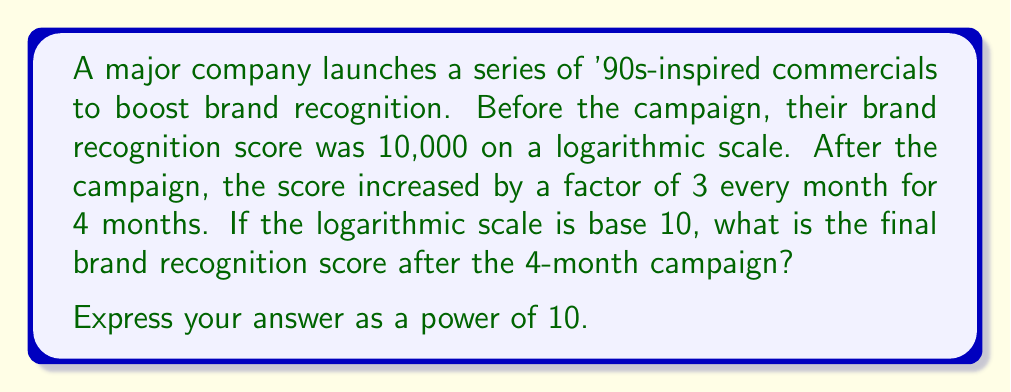Solve this math problem. Let's approach this step-by-step:

1) The initial brand recognition score is 10,000. On a base-10 logarithmic scale, this can be written as:

   $10,000 = 10^4$

2) The score increases by a factor of 3 every month for 4 months. We can represent this as:

   $10^4 \cdot 3^4$

3) Let's calculate $3^4$:

   $3^4 = 3 \cdot 3 \cdot 3 \cdot 3 = 81$

4) Now our expression is:

   $10^4 \cdot 81$

5) We can write 81 as a power of 10:

   $81 = 10^{1.908485...}$

6) So our expression becomes:

   $10^4 \cdot 10^{1.908485...} = 10^{5.908485...}$

7) Rounding to 6 decimal places, we get:

   $10^{5.908485}$

This is the final brand recognition score on the logarithmic scale after the 4-month campaign.
Answer: $10^{5.908485}$ 